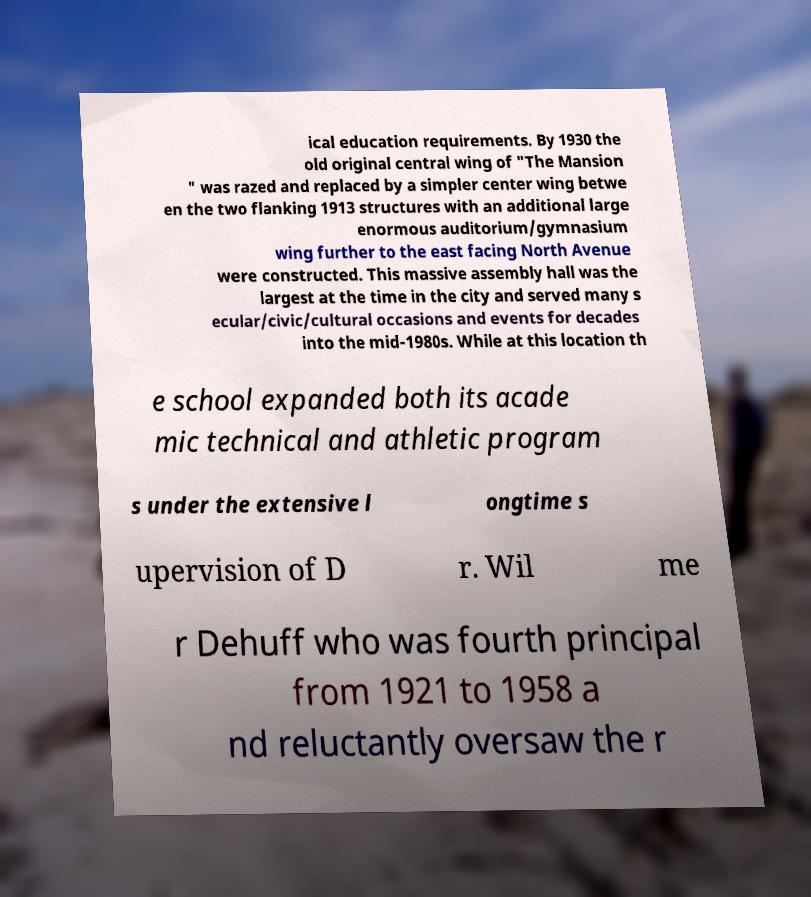Please identify and transcribe the text found in this image. ical education requirements. By 1930 the old original central wing of "The Mansion " was razed and replaced by a simpler center wing betwe en the two flanking 1913 structures with an additional large enormous auditorium/gymnasium wing further to the east facing North Avenue were constructed. This massive assembly hall was the largest at the time in the city and served many s ecular/civic/cultural occasions and events for decades into the mid-1980s. While at this location th e school expanded both its acade mic technical and athletic program s under the extensive l ongtime s upervision of D r. Wil me r Dehuff who was fourth principal from 1921 to 1958 a nd reluctantly oversaw the r 